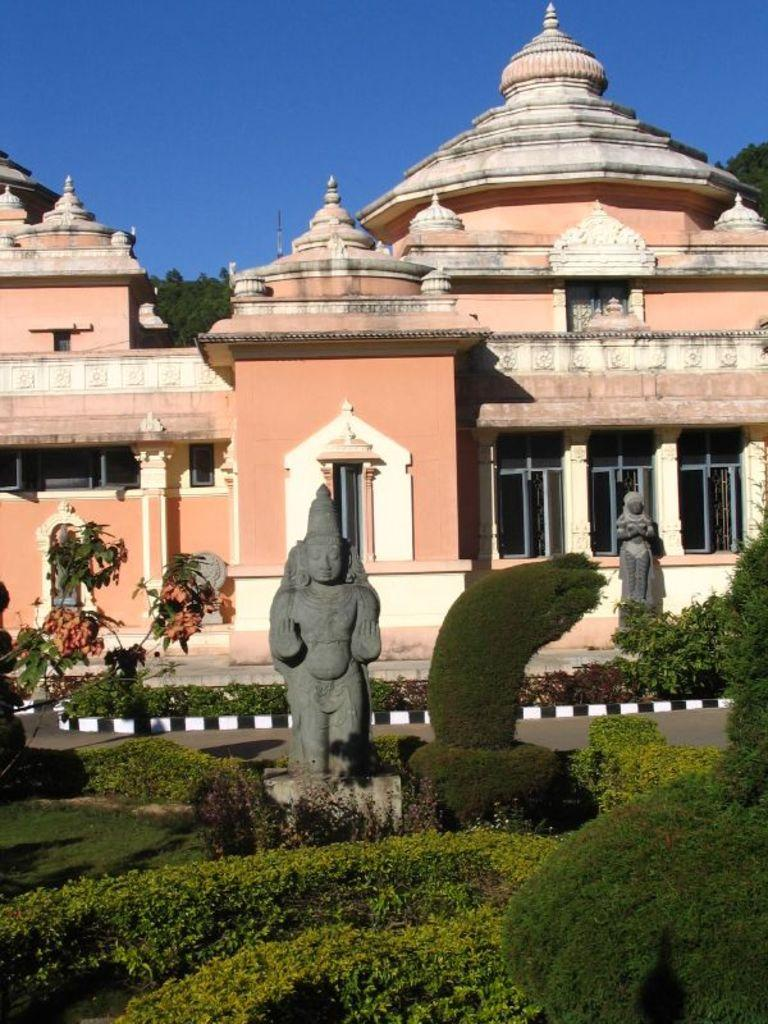What is the main subject of the image? There is a statue in the image. What is the color of the statue? The statue is gray in color. What other elements are present in the image besides the statue? There are plants, grass, a building, and the sky in the image. What is the color of the plants and grass? The plants and grass are gray in color. What is the color of the building in the background? The building is light orange in color. What is the color of the sky in the image? The sky is blue in color. Can you see any goldfish swimming in the image? There are no goldfish present in the image. What type of transport is visible in the image? There is no transport visible in the image. 